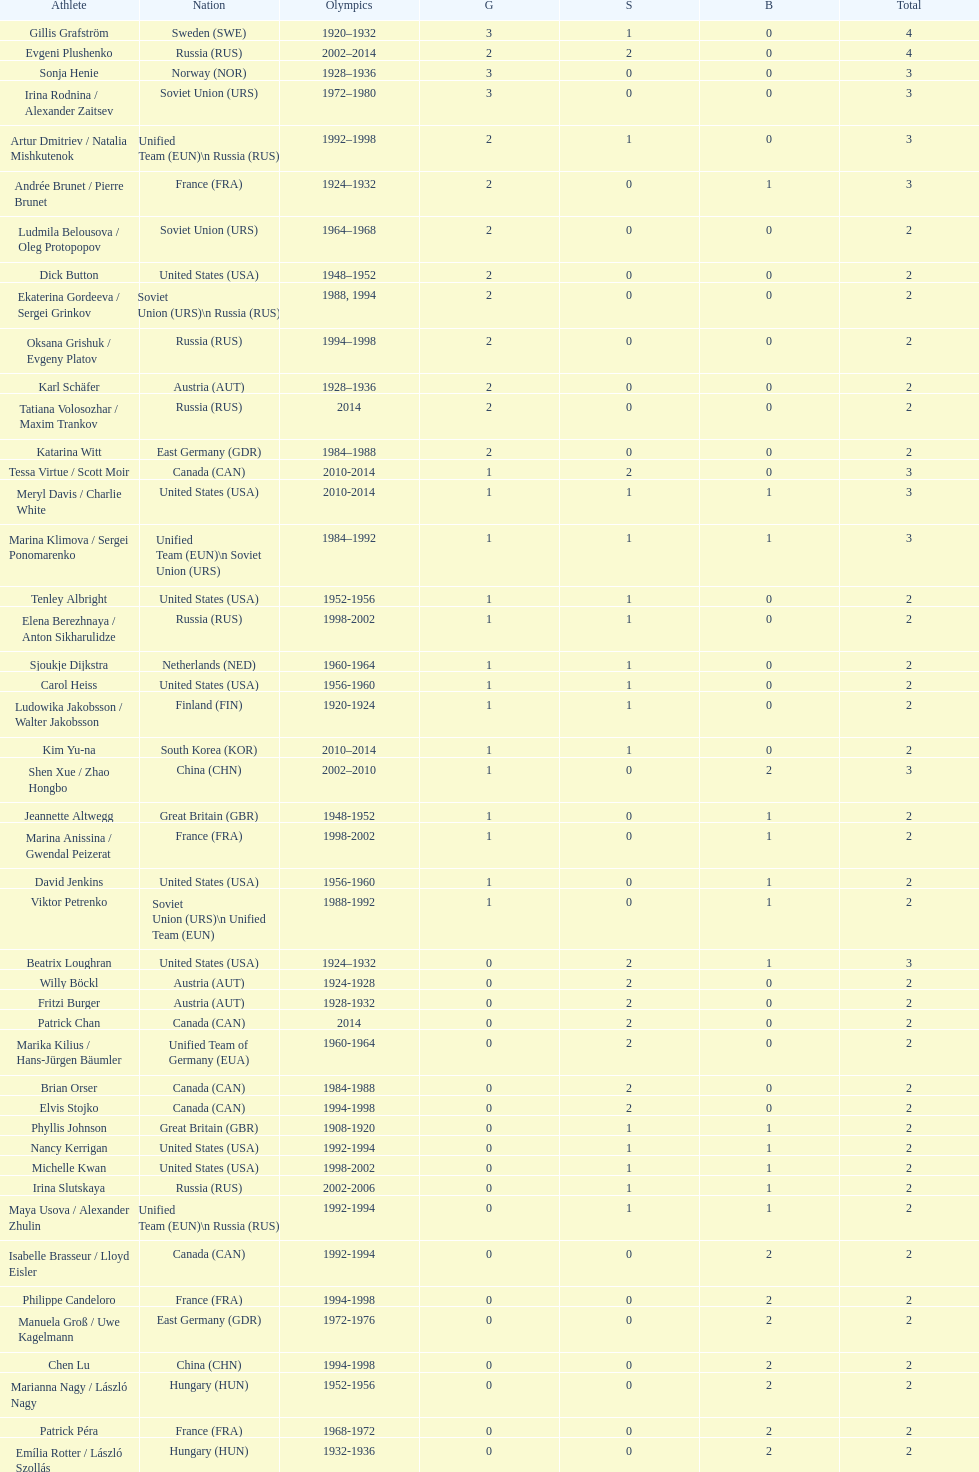Which nation first claimed three gold medals in olympic figure skating? Sweden. 